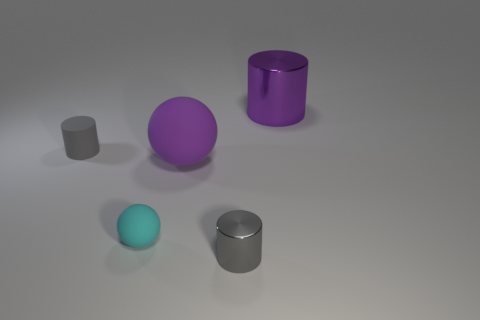Is the material of the tiny thing that is left of the small cyan ball the same as the big purple thing that is on the right side of the purple rubber thing?
Keep it short and to the point. No. How many balls are there?
Ensure brevity in your answer.  2. The gray matte object behind the tiny cyan rubber ball has what shape?
Your response must be concise. Cylinder. How many other objects are there of the same size as the gray metallic cylinder?
Your answer should be compact. 2. There is a purple matte object that is to the left of the tiny shiny cylinder; does it have the same shape as the gray thing in front of the tiny gray rubber cylinder?
Provide a short and direct response. No. How many things are in front of the tiny metallic cylinder?
Your response must be concise. 0. There is a rubber sphere that is to the right of the cyan thing; what color is it?
Your answer should be very brief. Purple. There is another object that is the same shape as the cyan object; what is its color?
Your answer should be compact. Purple. Are there any other things of the same color as the rubber cylinder?
Provide a succinct answer. Yes. Are there more big purple metallic cylinders than big green metal spheres?
Ensure brevity in your answer.  Yes. 